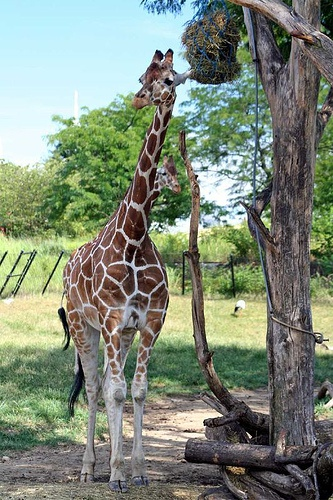Describe the objects in this image and their specific colors. I can see giraffe in lightblue, darkgray, gray, black, and maroon tones, giraffe in lightblue, gray, darkgray, and black tones, sheep in lightblue, ivory, beige, black, and darkgray tones, and bird in lightblue, ivory, khaki, black, and darkgray tones in this image. 